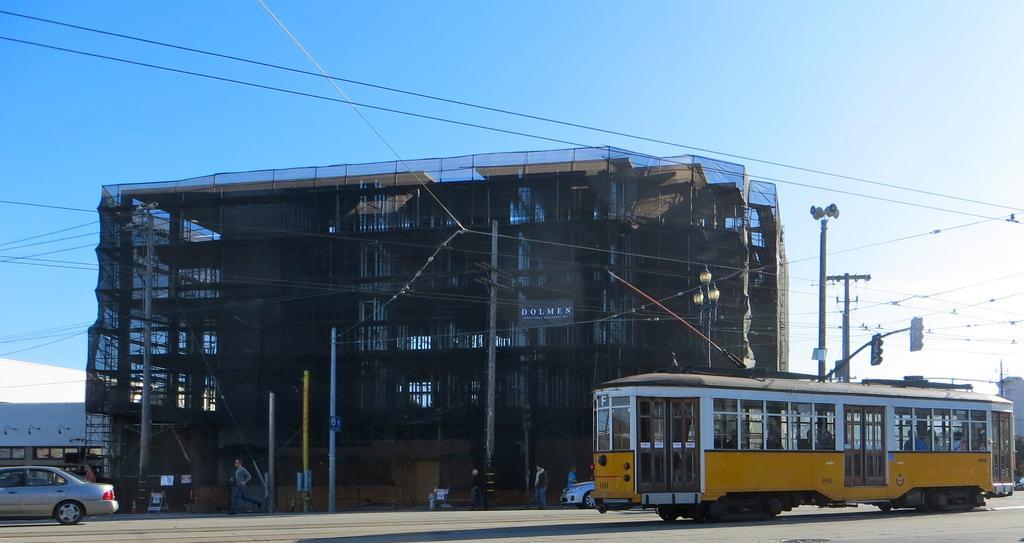Could you give a brief overview of what you see in this image? This image consists of a building. There is a car at the bottom. There is a bus on the right side. There is sky at the top. 